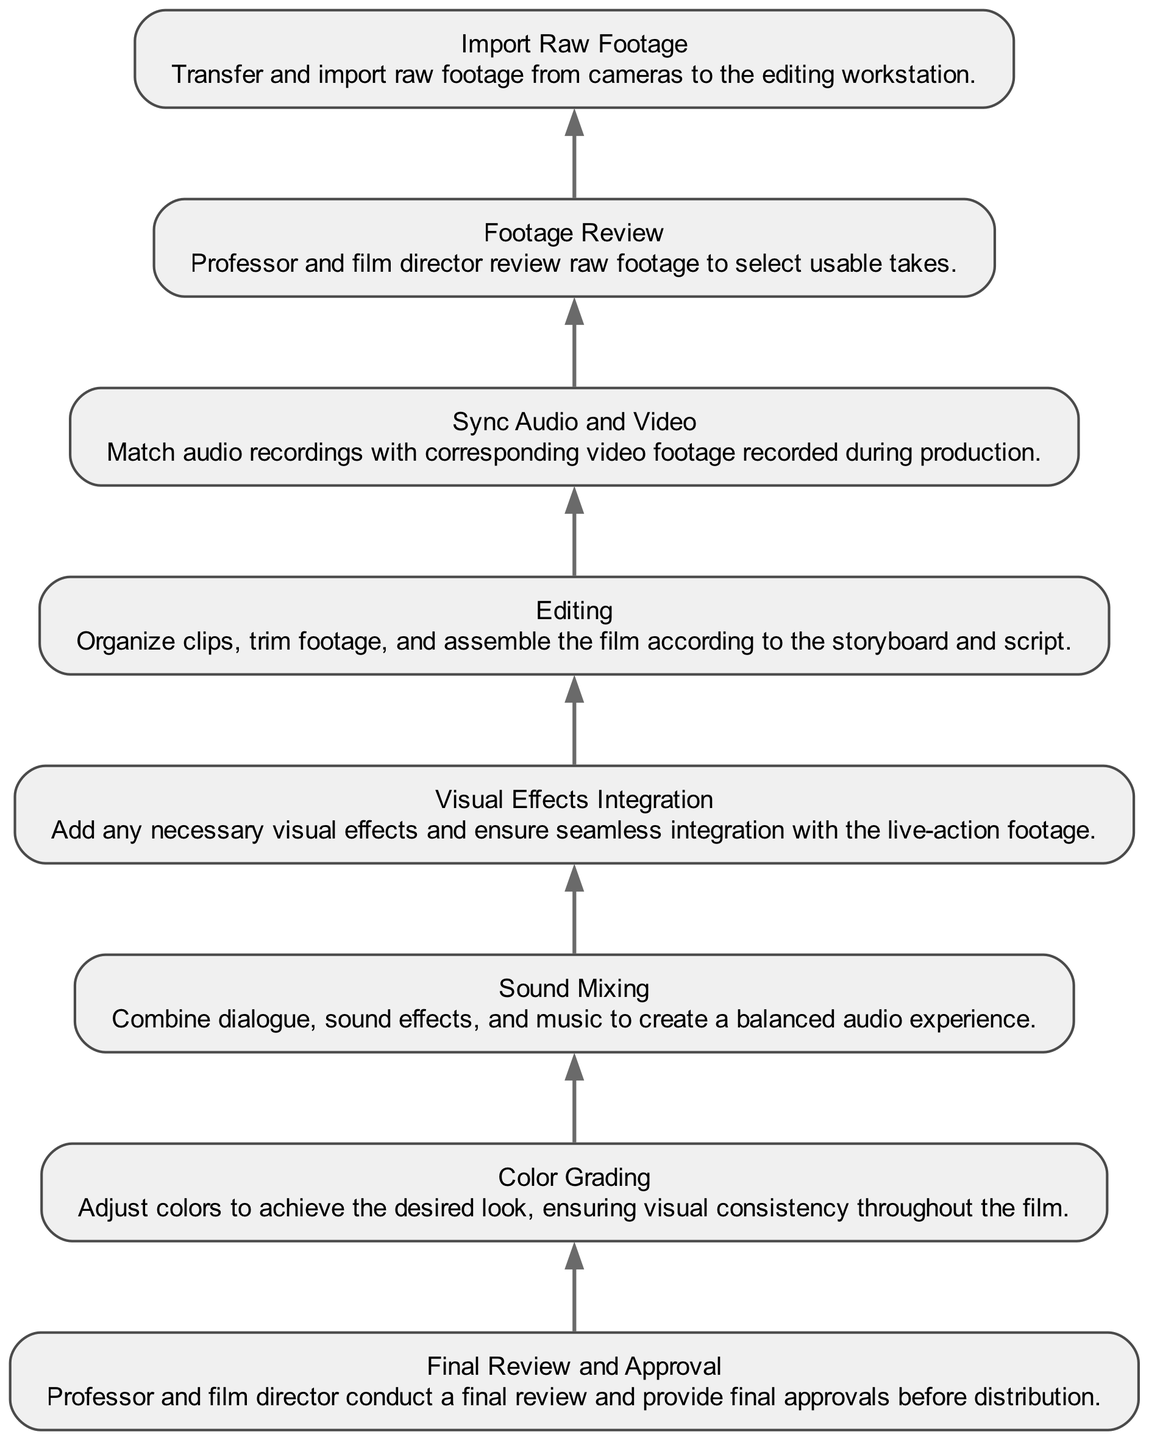What is the first step in the post-production workflow? The first step is "Import Raw Footage", as it is at the bottom of the flow chart, indicating it is the initial process where raw footage is transferred from cameras to the editing workstation.
Answer: Import Raw Footage How many total nodes are present in the diagram? There are eight nodes in the diagram, each representing a unique step in the post-production workflow for the collaborative educational film project.
Answer: 8 What step directly follows "Editing"? The step that directly follows "Editing" is "Sync Audio and Video", as per the flow from bottom to top, the arrows indicate the progression from editing to syncing audio with video footage.
Answer: Sync Audio and Video Who conducts the final review before distribution? The final review is conducted by "Professor and film director", as indicated in the "Final Review and Approval" node that specifies the approval process before distribution.
Answer: Professor and film director What is the relationship between "Footage Review" and "Editing"? "Footage Review" comes before "Editing"; the diagram indicates that footage selection must occur before editing can take place, as editors rely on selected takes to assemble the film.
Answer: Footage Review precedes Editing How many edge connections are there in the diagram? There are seven edges in the diagram, representing the connections between consecutive nodes indicating the flow of the post-production process.
Answer: 7 What is the purpose of "Color Grading"? The purpose of "Color Grading" is to adjust colors for a desired visual look and ensure consistency throughout the film as described in the node's details.
Answer: Adjust colors What is the last step in the workflow before distribution? The last step before distribution is "Final Review and Approval", which represents the final verification phase after all post-production tasks have been completed.
Answer: Final Review and Approval Which step comes immediately after "Visual Effects Integration"? The step that comes immediately after "Visual Effects Integration" is "Color Grading", as per the flow, indicating that visual effects should be integrated before color adjustments are made.
Answer: Color Grading 